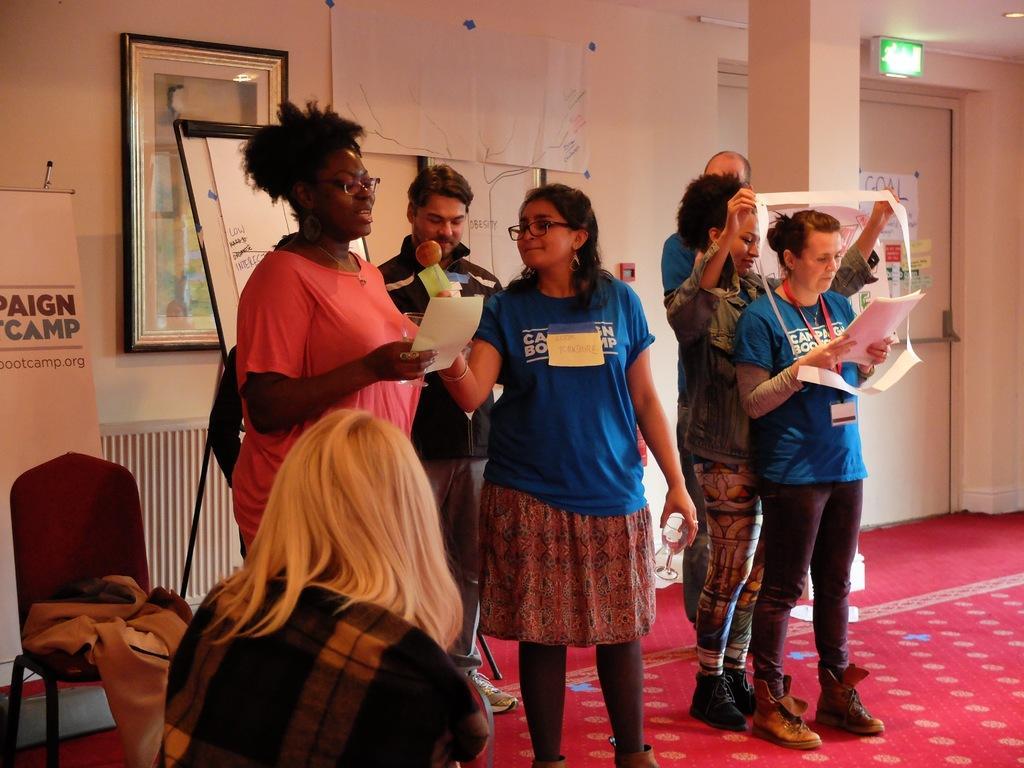Can you describe this image briefly? In this image there are group of persons standing and holding objects in their hands. In the background there is a board with some text written on it and on the wall there is a frame and there is a door, there are chairs and there is a banner with some text written on it. 